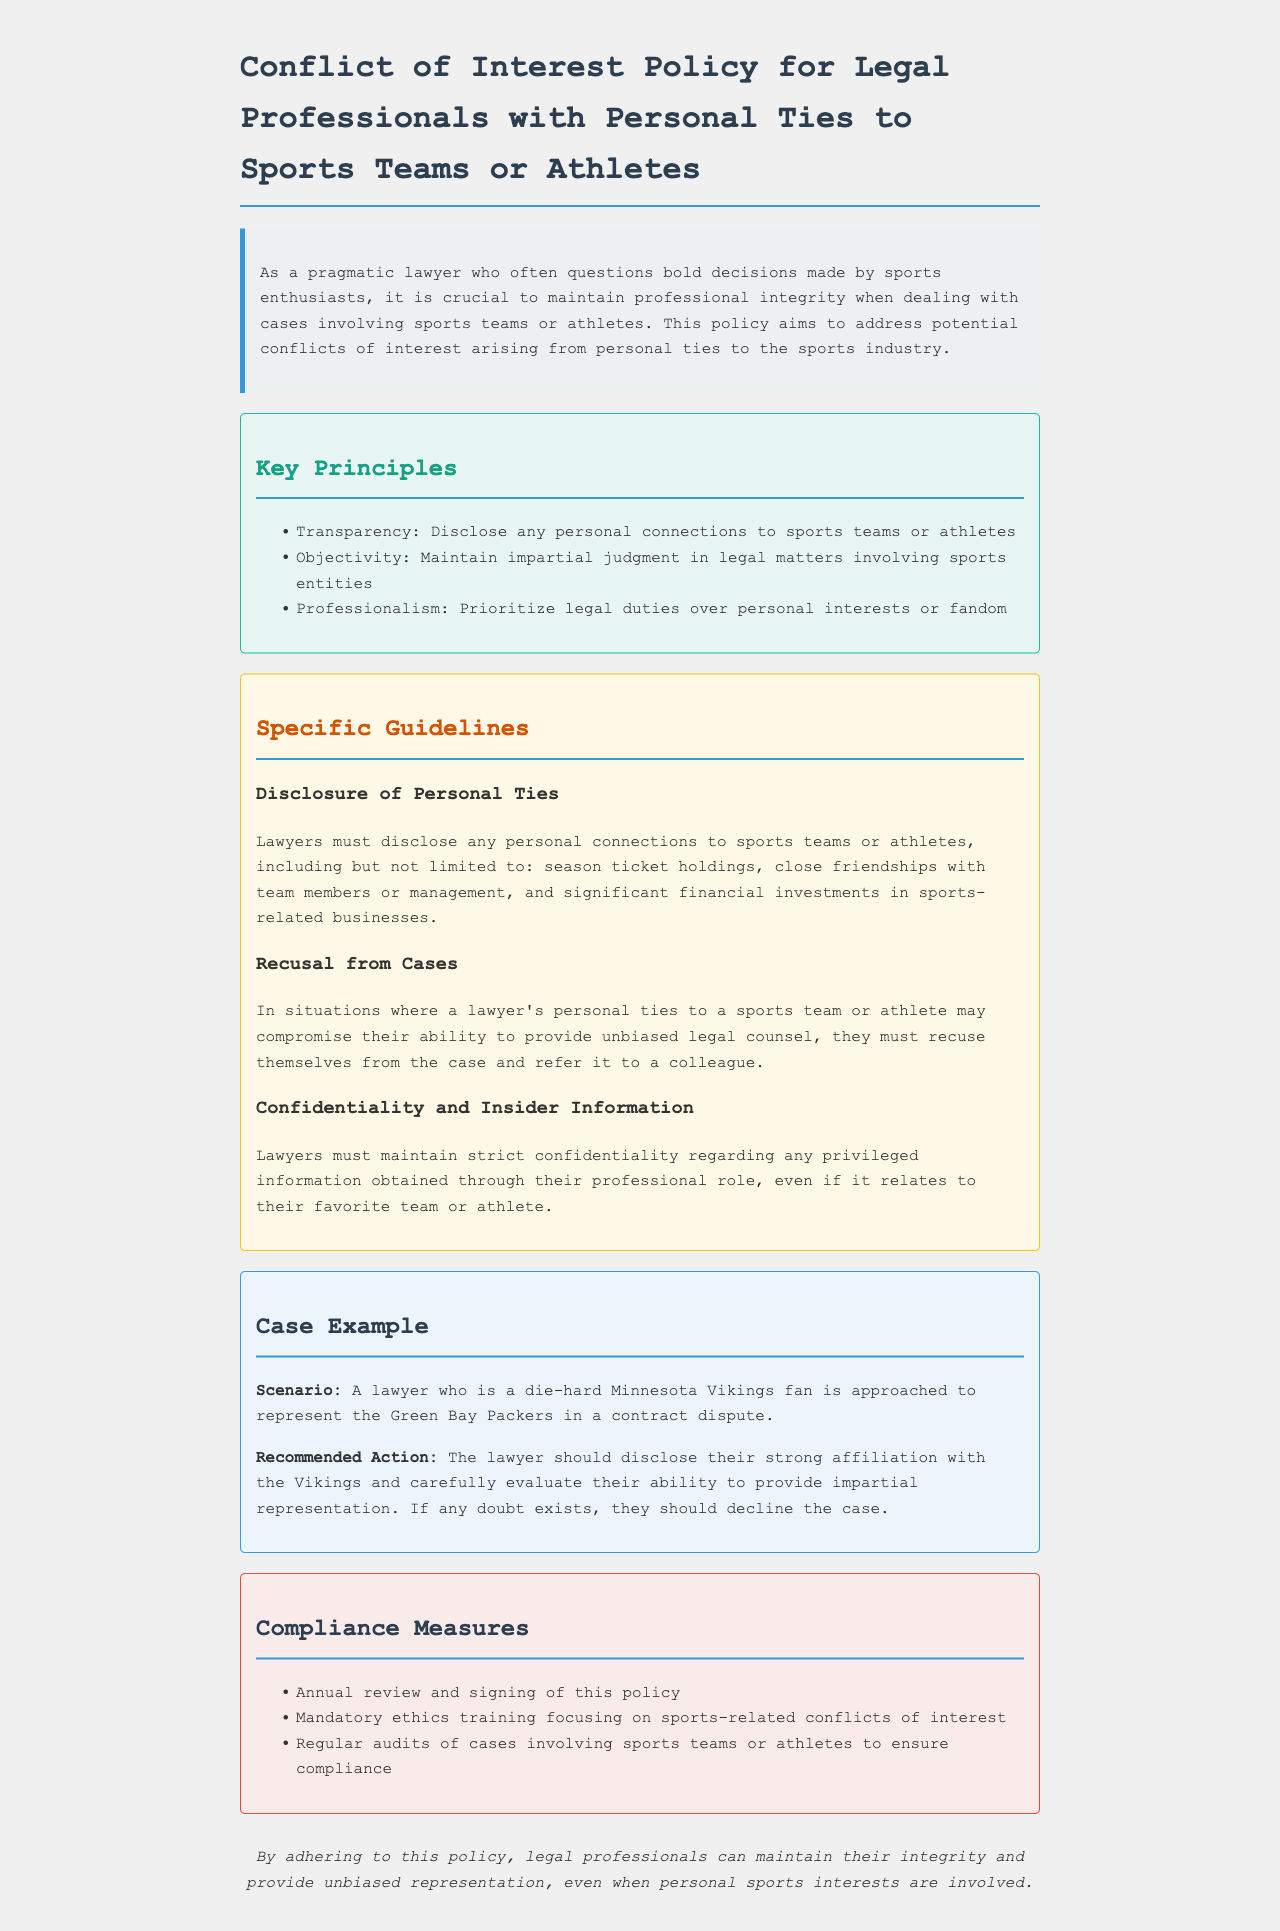What is the title of the policy document? The title of the document is stated prominently at the beginning, indicating the focus on conflicts of interest.
Answer: Conflict of Interest Policy for Legal Professionals with Personal Ties to Sports Teams or Athletes What is one key principle mentioned in the document? The key principles address the fundamental tenets that lawyers should uphold when dealing with potential conflicts.
Answer: Transparency What should lawyers disclose regarding sports teams? This refers to the specific guidelines regarding necessary disclosures related to personal connections to sports entities.
Answer: Personal connections to sports teams or athletes What action should a lawyer take if they have personal ties to a team involved in a case? This action is specified in the guidelines as a necessary step to maintain professional integrity in legal matters.
Answer: Recuse themselves What type of training is mandated by the compliance measures? The compliance measures include a specific area of training aimed at addressing conflicts of interest in the sports context.
Answer: Mandatory ethics training focusing on sports-related conflicts of interest How often should the policy be reviewed? The compliance measures detail the frequency of reviews to ensure adherence to the policy.
Answer: Annually In the case example, which team is the lawyer affiliated with? The example illustrates a scenario involving a personal tie to a specific sports team to highlight the conflict issue.
Answer: Minnesota Vikings What should a lawyer do if they doubt their ability to provide impartial representation? This decision is integral to maintaining professionalism and integrity in their legal responsibilities.
Answer: Decline the case 